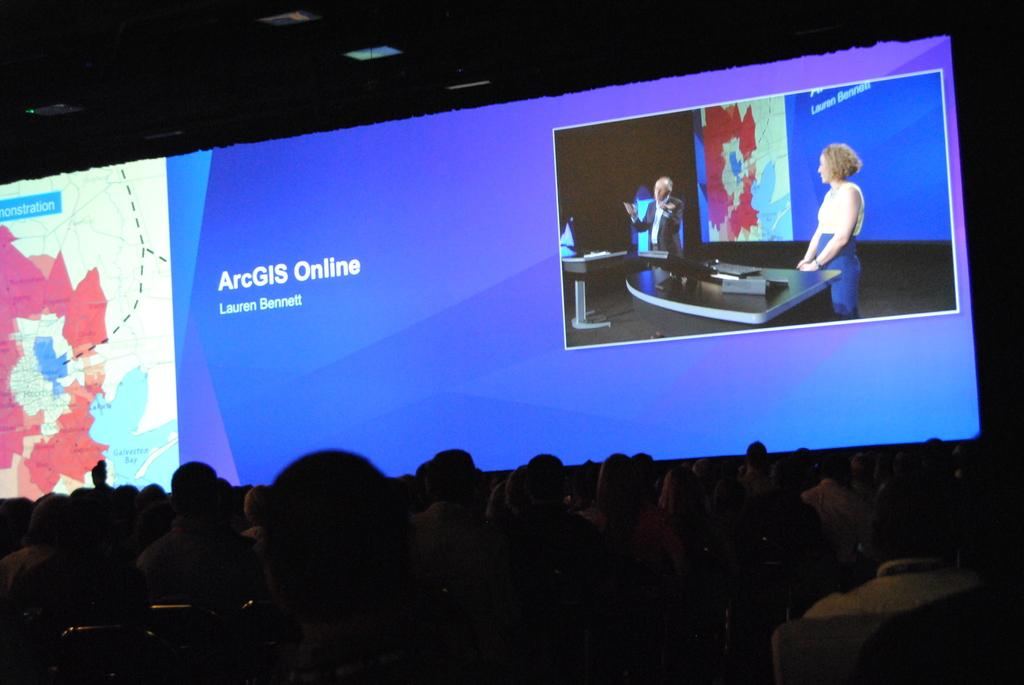<image>
Give a short and clear explanation of the subsequent image. A presentation slide reads ARCGIS online and Lauren Bennett. 